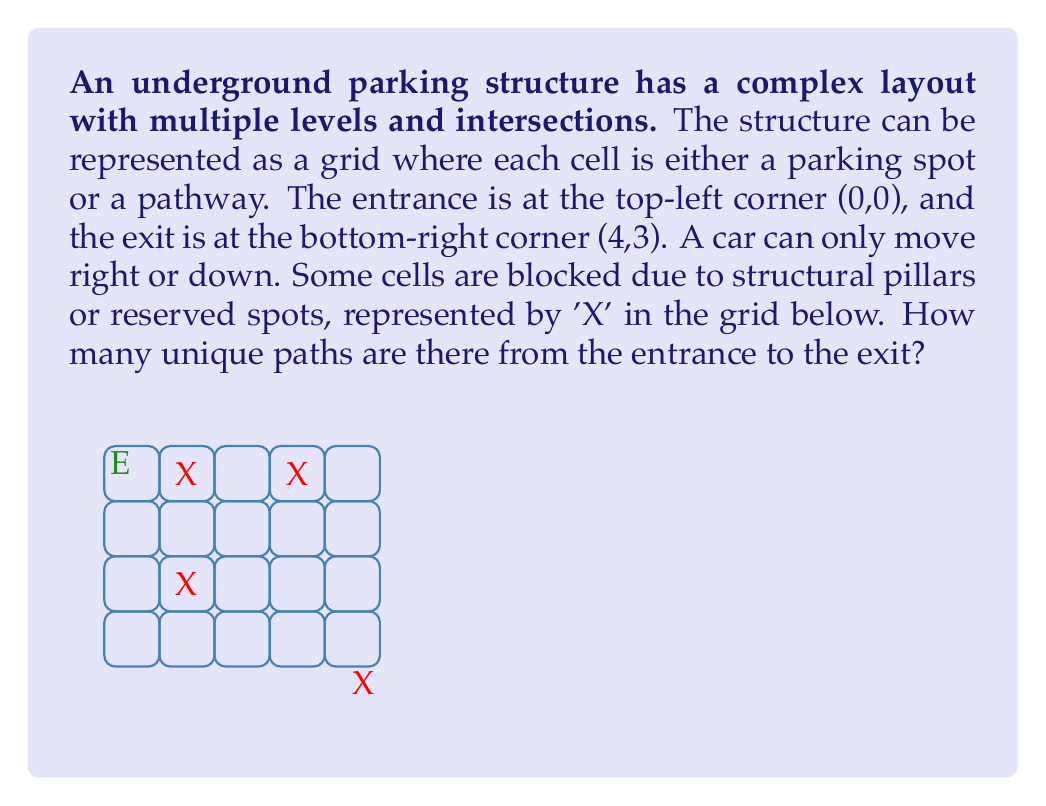Solve this math problem. To solve this problem, we can use dynamic programming. We'll create a 4x5 grid to represent the parking structure and fill it with the number of unique paths to reach each cell.

1) Initialize the grid:
   - Set the entrance (0,0) to 1
   - Set blocked cells (X) to 0
   - Set all other cells to 0 initially

2) Fill the grid:
   - For each cell (i,j), the number of paths to reach it is the sum of paths from the cell above (i-1,j) and the cell to the left (i,j-1)
   - If a cell is blocked (X), skip it

3) The formula for each cell (i,j) is:
   $$ grid[i][j] = grid[i-1][j] + grid[i][j-1] $$
   (if the cell is not blocked and both i and j are greater than 0)

4) Fill the grid row by row, column by column:

   $$ \begin{bmatrix}
   1 & 1 & 1 & 1 & 1 \\
   1 & 0 & 1 & 0 & 1 \\
   1 & 1 & 2 & 2 & 3 \\
   1 & 0 & 2 & 4 & 7
   \end{bmatrix} $$

5) The bottom-right cell (4,3) contains the total number of unique paths from the entrance to the exit.

Therefore, there are 7 unique paths from the entrance to the exit in this underground parking layout.
Answer: 7 